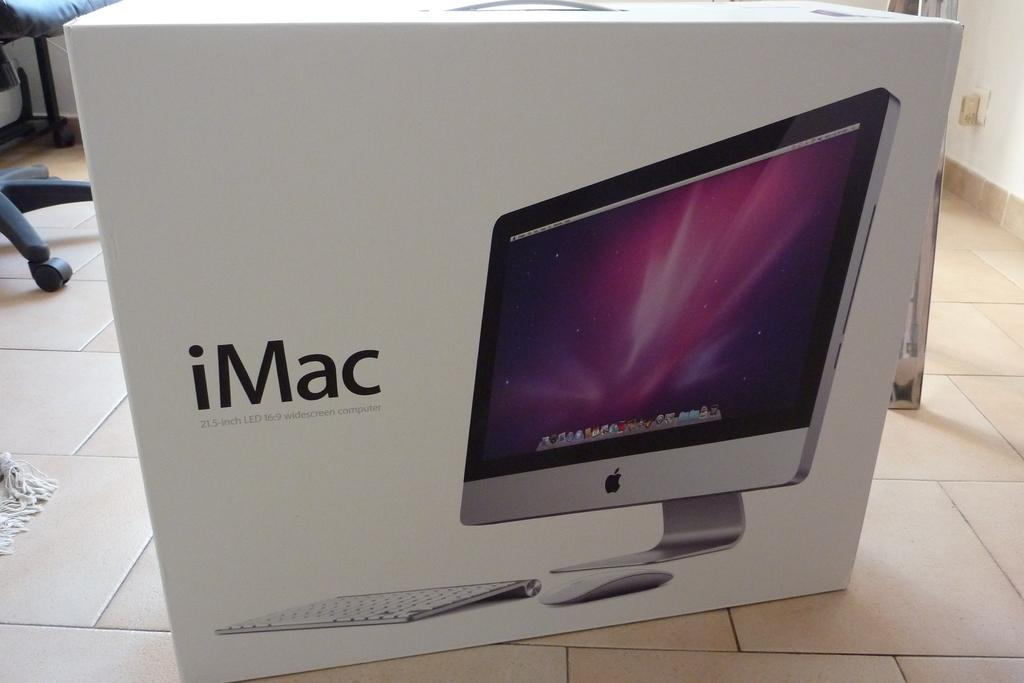<image>
Offer a succinct explanation of the picture presented. imac computer that is new in a white box that never been open 